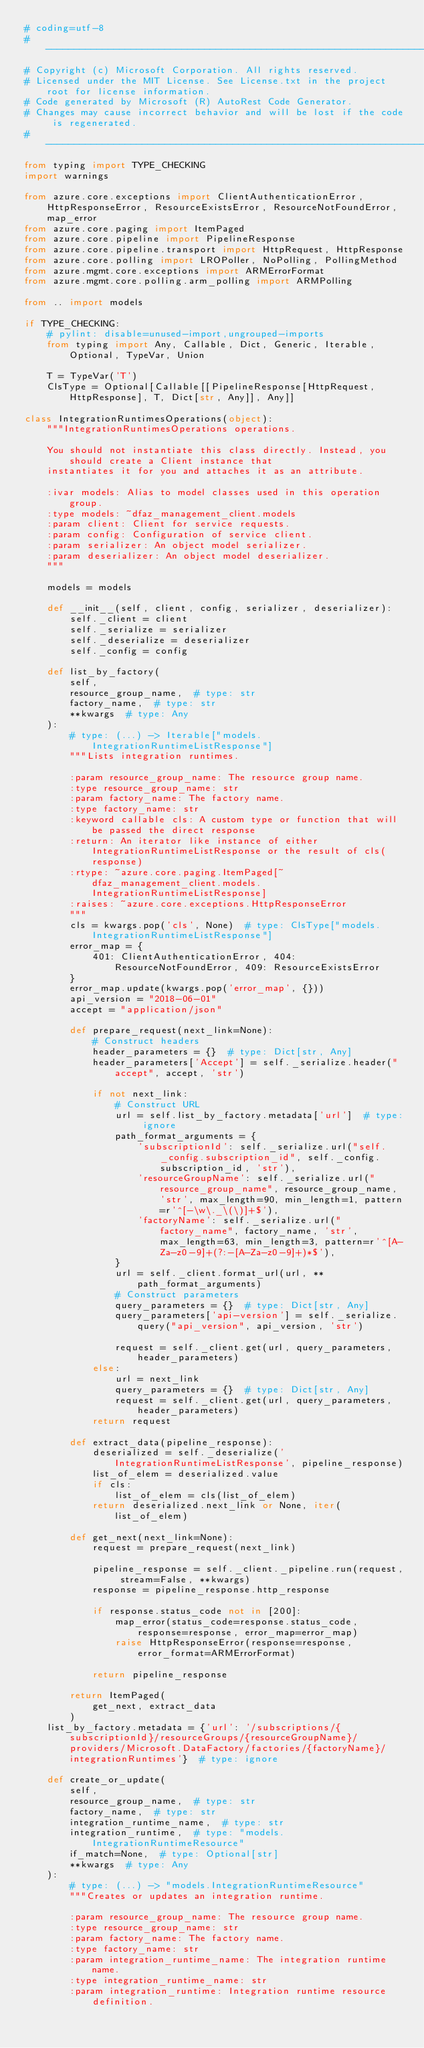Convert code to text. <code><loc_0><loc_0><loc_500><loc_500><_Python_># coding=utf-8
# --------------------------------------------------------------------------
# Copyright (c) Microsoft Corporation. All rights reserved.
# Licensed under the MIT License. See License.txt in the project root for license information.
# Code generated by Microsoft (R) AutoRest Code Generator.
# Changes may cause incorrect behavior and will be lost if the code is regenerated.
# --------------------------------------------------------------------------
from typing import TYPE_CHECKING
import warnings

from azure.core.exceptions import ClientAuthenticationError, HttpResponseError, ResourceExistsError, ResourceNotFoundError, map_error
from azure.core.paging import ItemPaged
from azure.core.pipeline import PipelineResponse
from azure.core.pipeline.transport import HttpRequest, HttpResponse
from azure.core.polling import LROPoller, NoPolling, PollingMethod
from azure.mgmt.core.exceptions import ARMErrorFormat
from azure.mgmt.core.polling.arm_polling import ARMPolling

from .. import models

if TYPE_CHECKING:
    # pylint: disable=unused-import,ungrouped-imports
    from typing import Any, Callable, Dict, Generic, Iterable, Optional, TypeVar, Union

    T = TypeVar('T')
    ClsType = Optional[Callable[[PipelineResponse[HttpRequest, HttpResponse], T, Dict[str, Any]], Any]]

class IntegrationRuntimesOperations(object):
    """IntegrationRuntimesOperations operations.

    You should not instantiate this class directly. Instead, you should create a Client instance that
    instantiates it for you and attaches it as an attribute.

    :ivar models: Alias to model classes used in this operation group.
    :type models: ~dfaz_management_client.models
    :param client: Client for service requests.
    :param config: Configuration of service client.
    :param serializer: An object model serializer.
    :param deserializer: An object model deserializer.
    """

    models = models

    def __init__(self, client, config, serializer, deserializer):
        self._client = client
        self._serialize = serializer
        self._deserialize = deserializer
        self._config = config

    def list_by_factory(
        self,
        resource_group_name,  # type: str
        factory_name,  # type: str
        **kwargs  # type: Any
    ):
        # type: (...) -> Iterable["models.IntegrationRuntimeListResponse"]
        """Lists integration runtimes.

        :param resource_group_name: The resource group name.
        :type resource_group_name: str
        :param factory_name: The factory name.
        :type factory_name: str
        :keyword callable cls: A custom type or function that will be passed the direct response
        :return: An iterator like instance of either IntegrationRuntimeListResponse or the result of cls(response)
        :rtype: ~azure.core.paging.ItemPaged[~dfaz_management_client.models.IntegrationRuntimeListResponse]
        :raises: ~azure.core.exceptions.HttpResponseError
        """
        cls = kwargs.pop('cls', None)  # type: ClsType["models.IntegrationRuntimeListResponse"]
        error_map = {
            401: ClientAuthenticationError, 404: ResourceNotFoundError, 409: ResourceExistsError
        }
        error_map.update(kwargs.pop('error_map', {}))
        api_version = "2018-06-01"
        accept = "application/json"

        def prepare_request(next_link=None):
            # Construct headers
            header_parameters = {}  # type: Dict[str, Any]
            header_parameters['Accept'] = self._serialize.header("accept", accept, 'str')

            if not next_link:
                # Construct URL
                url = self.list_by_factory.metadata['url']  # type: ignore
                path_format_arguments = {
                    'subscriptionId': self._serialize.url("self._config.subscription_id", self._config.subscription_id, 'str'),
                    'resourceGroupName': self._serialize.url("resource_group_name", resource_group_name, 'str', max_length=90, min_length=1, pattern=r'^[-\w\._\(\)]+$'),
                    'factoryName': self._serialize.url("factory_name", factory_name, 'str', max_length=63, min_length=3, pattern=r'^[A-Za-z0-9]+(?:-[A-Za-z0-9]+)*$'),
                }
                url = self._client.format_url(url, **path_format_arguments)
                # Construct parameters
                query_parameters = {}  # type: Dict[str, Any]
                query_parameters['api-version'] = self._serialize.query("api_version", api_version, 'str')

                request = self._client.get(url, query_parameters, header_parameters)
            else:
                url = next_link
                query_parameters = {}  # type: Dict[str, Any]
                request = self._client.get(url, query_parameters, header_parameters)
            return request

        def extract_data(pipeline_response):
            deserialized = self._deserialize('IntegrationRuntimeListResponse', pipeline_response)
            list_of_elem = deserialized.value
            if cls:
                list_of_elem = cls(list_of_elem)
            return deserialized.next_link or None, iter(list_of_elem)

        def get_next(next_link=None):
            request = prepare_request(next_link)

            pipeline_response = self._client._pipeline.run(request, stream=False, **kwargs)
            response = pipeline_response.http_response

            if response.status_code not in [200]:
                map_error(status_code=response.status_code, response=response, error_map=error_map)
                raise HttpResponseError(response=response, error_format=ARMErrorFormat)

            return pipeline_response

        return ItemPaged(
            get_next, extract_data
        )
    list_by_factory.metadata = {'url': '/subscriptions/{subscriptionId}/resourceGroups/{resourceGroupName}/providers/Microsoft.DataFactory/factories/{factoryName}/integrationRuntimes'}  # type: ignore

    def create_or_update(
        self,
        resource_group_name,  # type: str
        factory_name,  # type: str
        integration_runtime_name,  # type: str
        integration_runtime,  # type: "models.IntegrationRuntimeResource"
        if_match=None,  # type: Optional[str]
        **kwargs  # type: Any
    ):
        # type: (...) -> "models.IntegrationRuntimeResource"
        """Creates or updates an integration runtime.

        :param resource_group_name: The resource group name.
        :type resource_group_name: str
        :param factory_name: The factory name.
        :type factory_name: str
        :param integration_runtime_name: The integration runtime name.
        :type integration_runtime_name: str
        :param integration_runtime: Integration runtime resource definition.</code> 